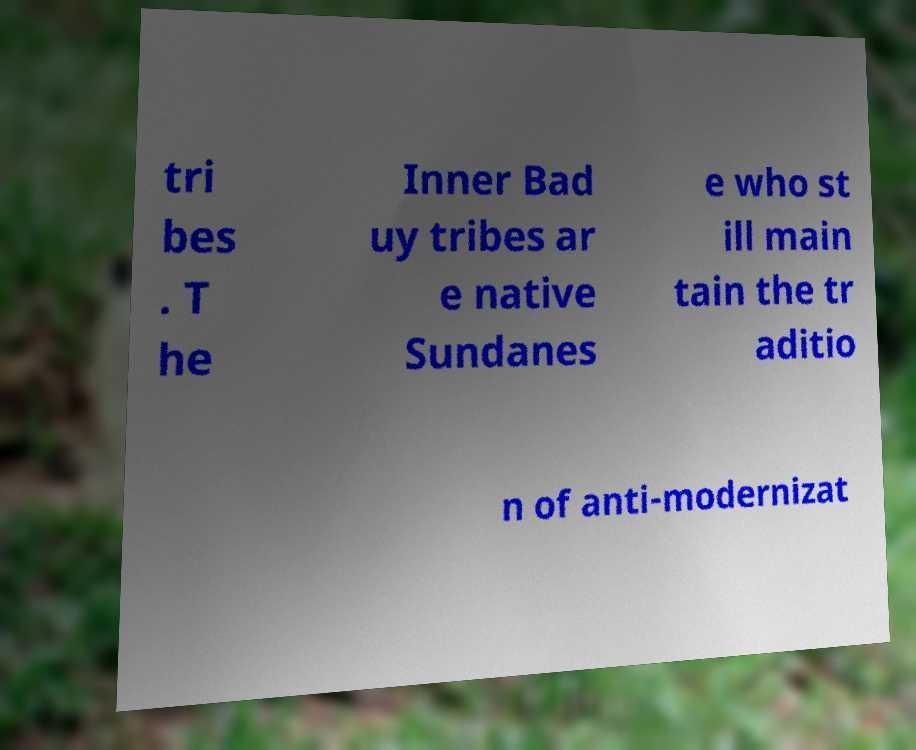Could you assist in decoding the text presented in this image and type it out clearly? tri bes . T he Inner Bad uy tribes ar e native Sundanes e who st ill main tain the tr aditio n of anti-modernizat 